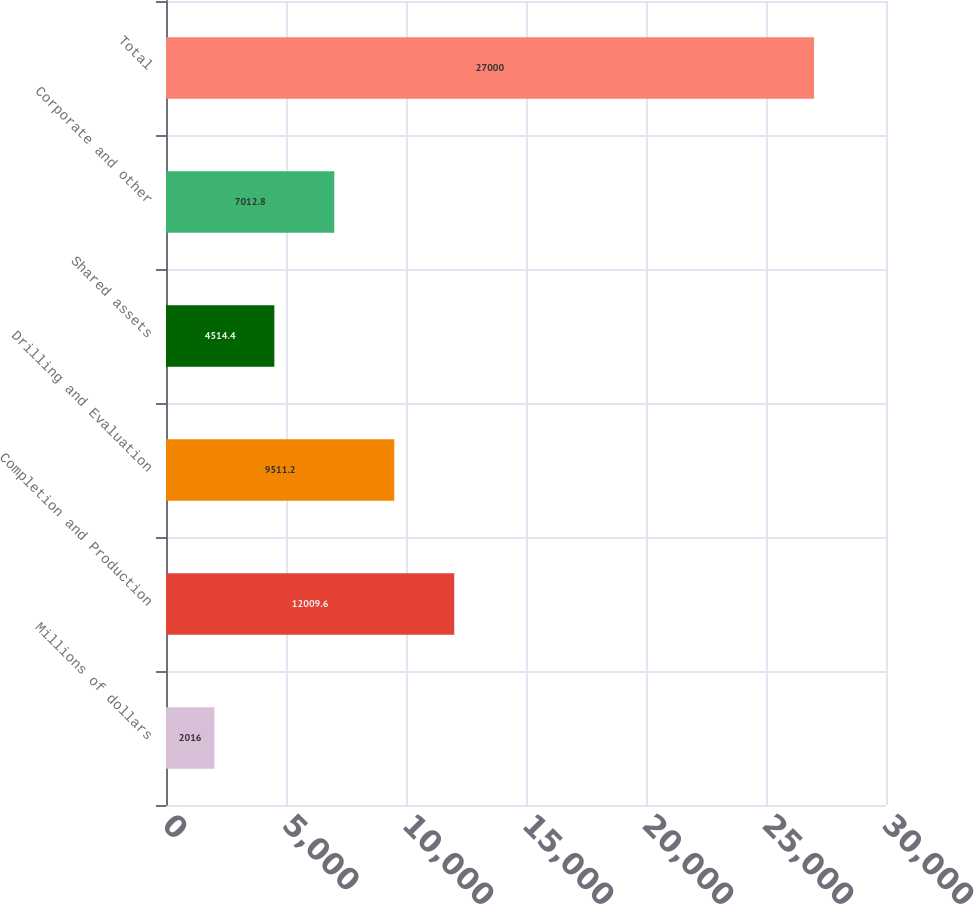<chart> <loc_0><loc_0><loc_500><loc_500><bar_chart><fcel>Millions of dollars<fcel>Completion and Production<fcel>Drilling and Evaluation<fcel>Shared assets<fcel>Corporate and other<fcel>Total<nl><fcel>2016<fcel>12009.6<fcel>9511.2<fcel>4514.4<fcel>7012.8<fcel>27000<nl></chart> 